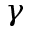Convert formula to latex. <formula><loc_0><loc_0><loc_500><loc_500>\gamma</formula> 